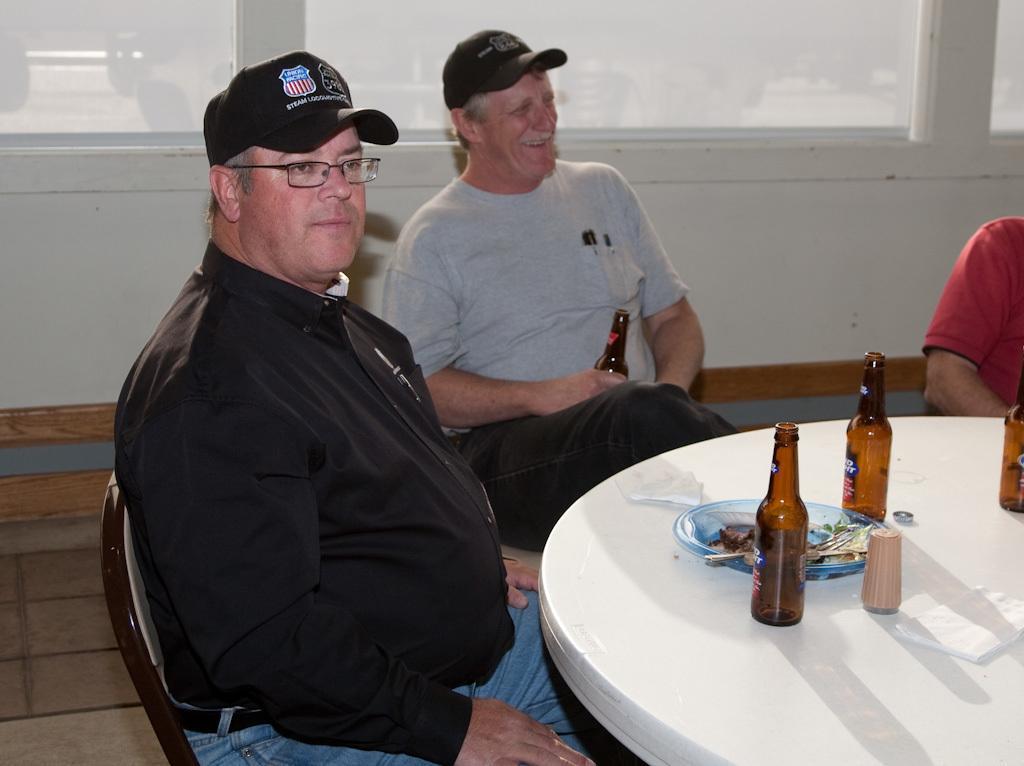In one or two sentences, can you explain what this image depicts? In this image we have three people were sitting on the chair in front of the table. The person in the middle is holding a glass bottle and these people are wearing a black hat and the person on the left side is wearing a black jacket and spectacles. On the table we have couple of glass bottles and a plate 